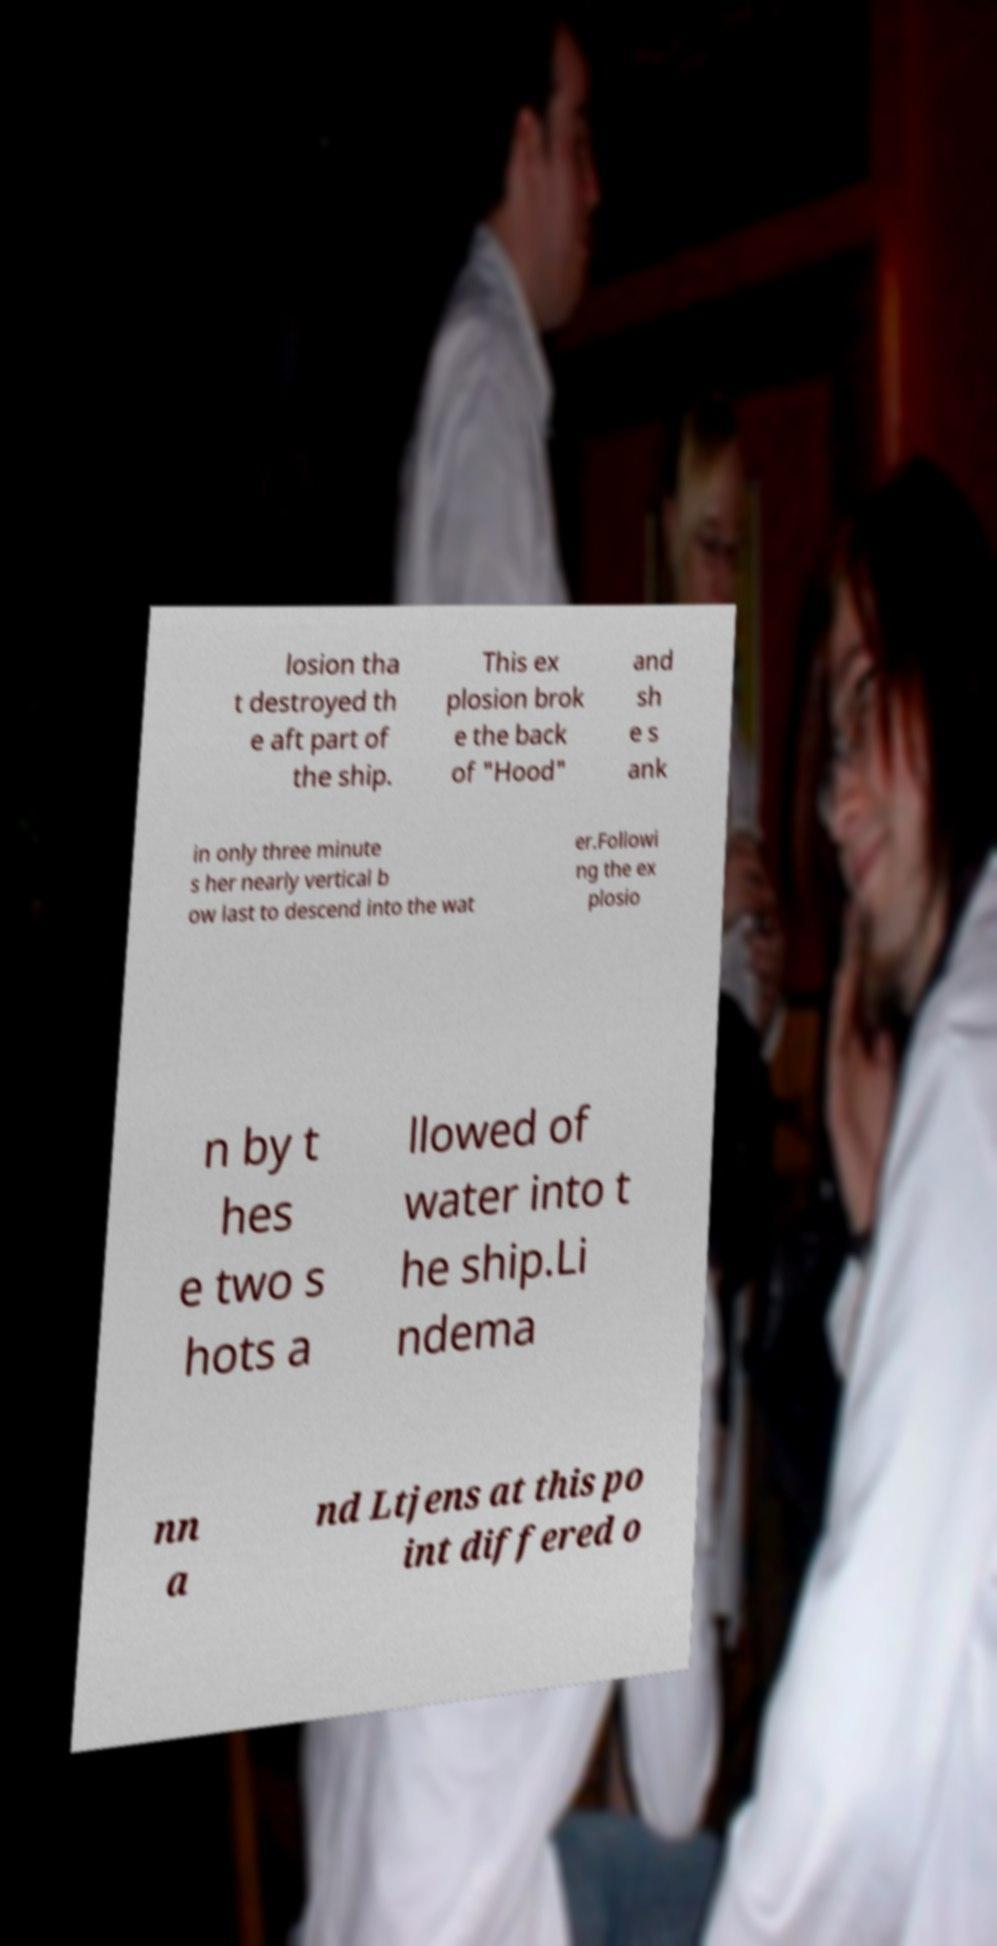I need the written content from this picture converted into text. Can you do that? losion tha t destroyed th e aft part of the ship. This ex plosion brok e the back of "Hood" and sh e s ank in only three minute s her nearly vertical b ow last to descend into the wat er.Followi ng the ex plosio n by t hes e two s hots a llowed of water into t he ship.Li ndema nn a nd Ltjens at this po int differed o 